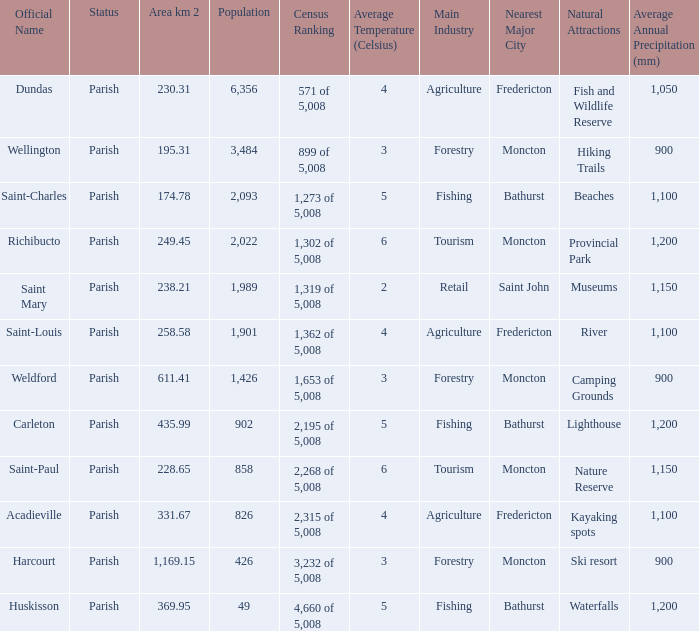For Saint-Paul parish, if it has an area of over 228.65 kilometers how many people live there? 0.0. 